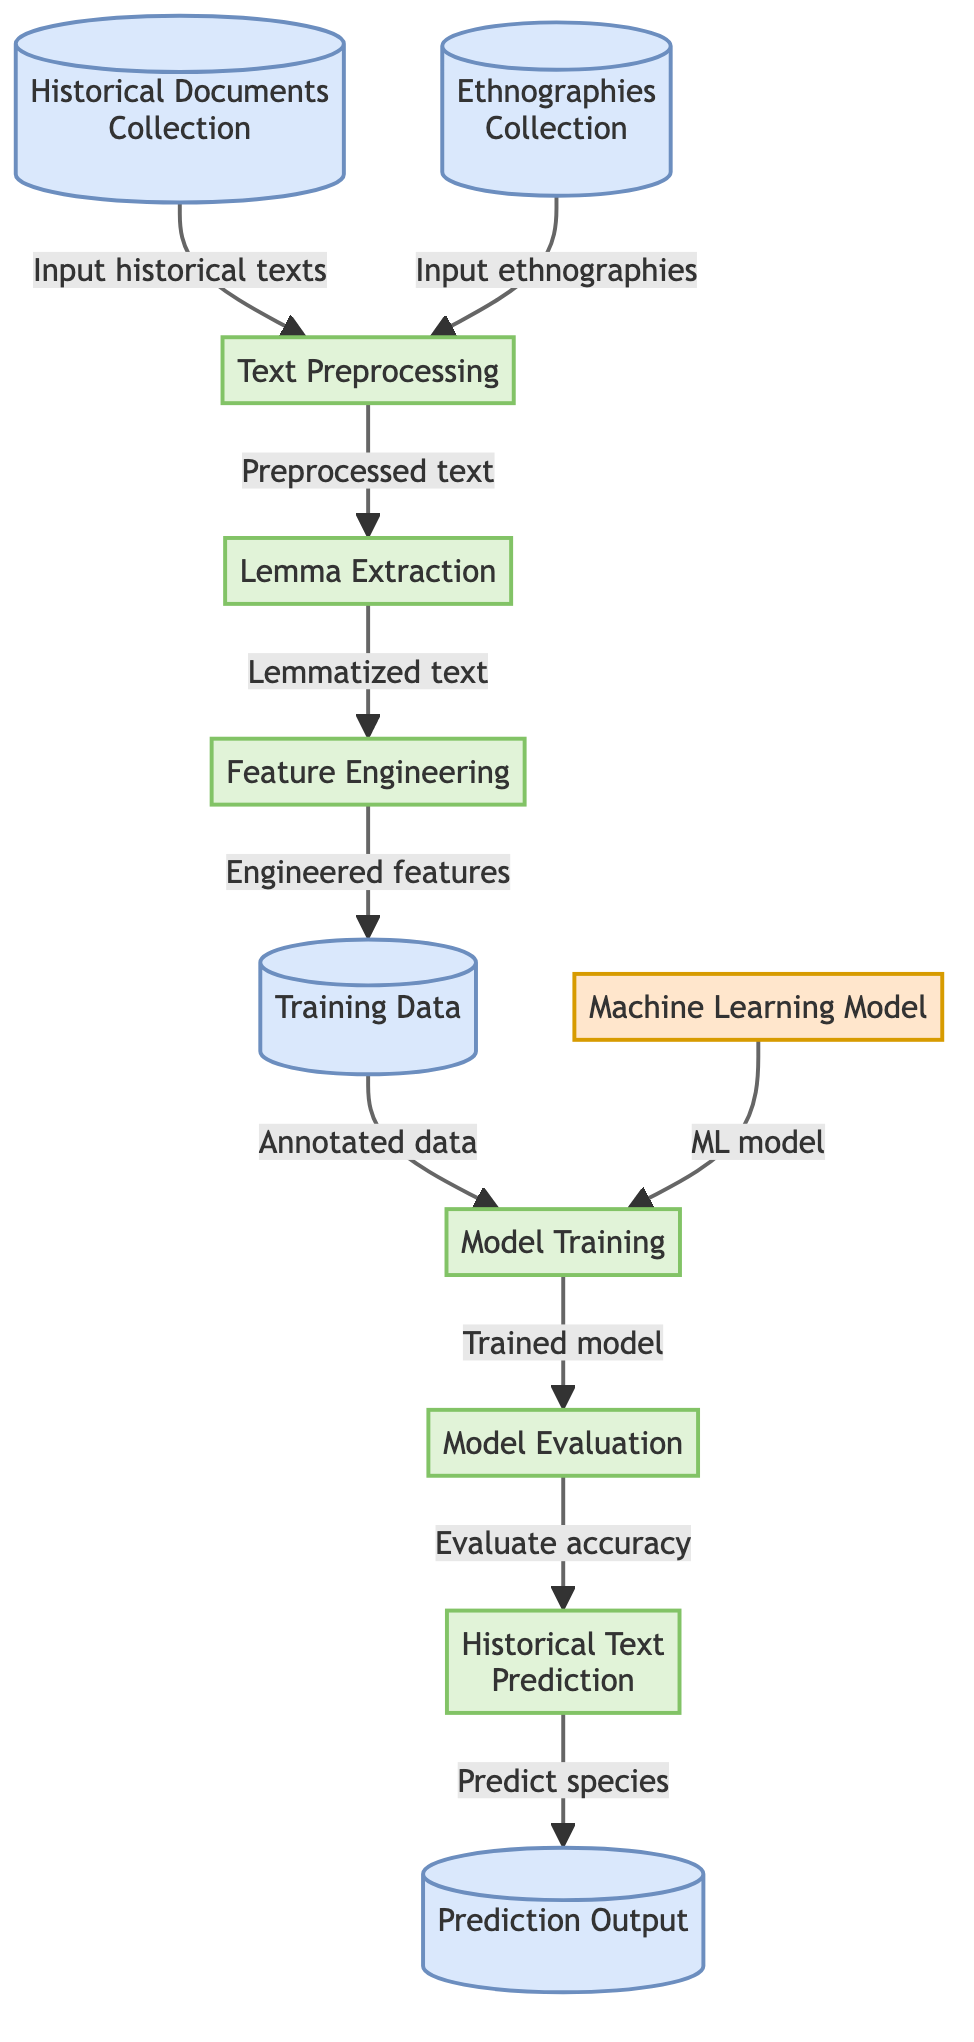What are the two types of data inputs in the diagram? The diagram shows two data input nodes: "Historical Documents Collection" and "Ethnographies Collection." These nodes represent the sources from which the textual data is gathered for further processing.
Answer: Historical Documents Collection and Ethnographies Collection How many processes are illustrated in the diagram? By examining the diagram, we can count the process nodes: "Text Preprocessing," "Lemma Extraction," "Feature Engineering," "Model Training," and "Model Evaluation," which totals five processes that outline the workflow involved in machine learning.
Answer: 5 What is the output of the "Model Evaluation" process? The "Model Evaluation" process connects to the "Historical Text Prediction" process, indicating that the output of evaluating the model is to proceed to predict the species based on the historical text.
Answer: Predict species Which two nodes are directly connected to "Feature Engineering"? Looking at "Feature Engineering," we see it has direct input from "Lemma Extraction" and gives output to "Training Data." This clearly identifies both connections it has in the diagram.
Answer: Lemma Extraction and Training Data What step follows "Training Data" in the diagram? The flow from "Training Data" leads directly to the "Model Training" process, indicating that it uses the training data to train the machine learning model.
Answer: Model Training What is the final output of the diagram? The final output, as shown in the diagram, is connected to the "Prediction Output" node, which receives its input from the "Historical Text Prediction" process. This signifies the culmination of the predictive analysis.
Answer: Prediction Output What is the purpose of the "Text Preprocessing" node? The "Text Preprocessing" node is the first processing step that prepares the collected text data from historical documents and ethnographies for subsequent lemmatization and feature extraction, setting the stage for effective machine learning.
Answer: Prepare text data Which node evaluates the performance of the machine learning model? The diagram shows that "Model Evaluation" is the dedicated process that assesses how well the machine learning model performs through accuracy checks before making predictions on plant species.
Answer: Model Evaluation What type of algorithms are implied in the "Machine Learning Model" node? This node likely refers to supervised or unsupervised learning algorithms employed to analyze the features derived from the preprocessed text and make predictions about plant species.
Answer: Machine learning algorithms 